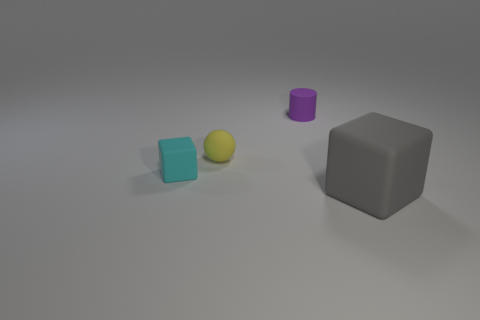Add 2 large gray matte objects. How many objects exist? 6 Subtract all gray blocks. How many blocks are left? 1 Subtract 1 balls. How many balls are left? 0 Subtract all brown balls. Subtract all red cubes. How many balls are left? 1 Add 4 tiny cubes. How many tiny cubes are left? 5 Add 3 large blue matte cylinders. How many large blue matte cylinders exist? 3 Subtract 0 cyan spheres. How many objects are left? 4 Subtract all spheres. How many objects are left? 3 Subtract all red balls. Subtract all cyan cubes. How many objects are left? 3 